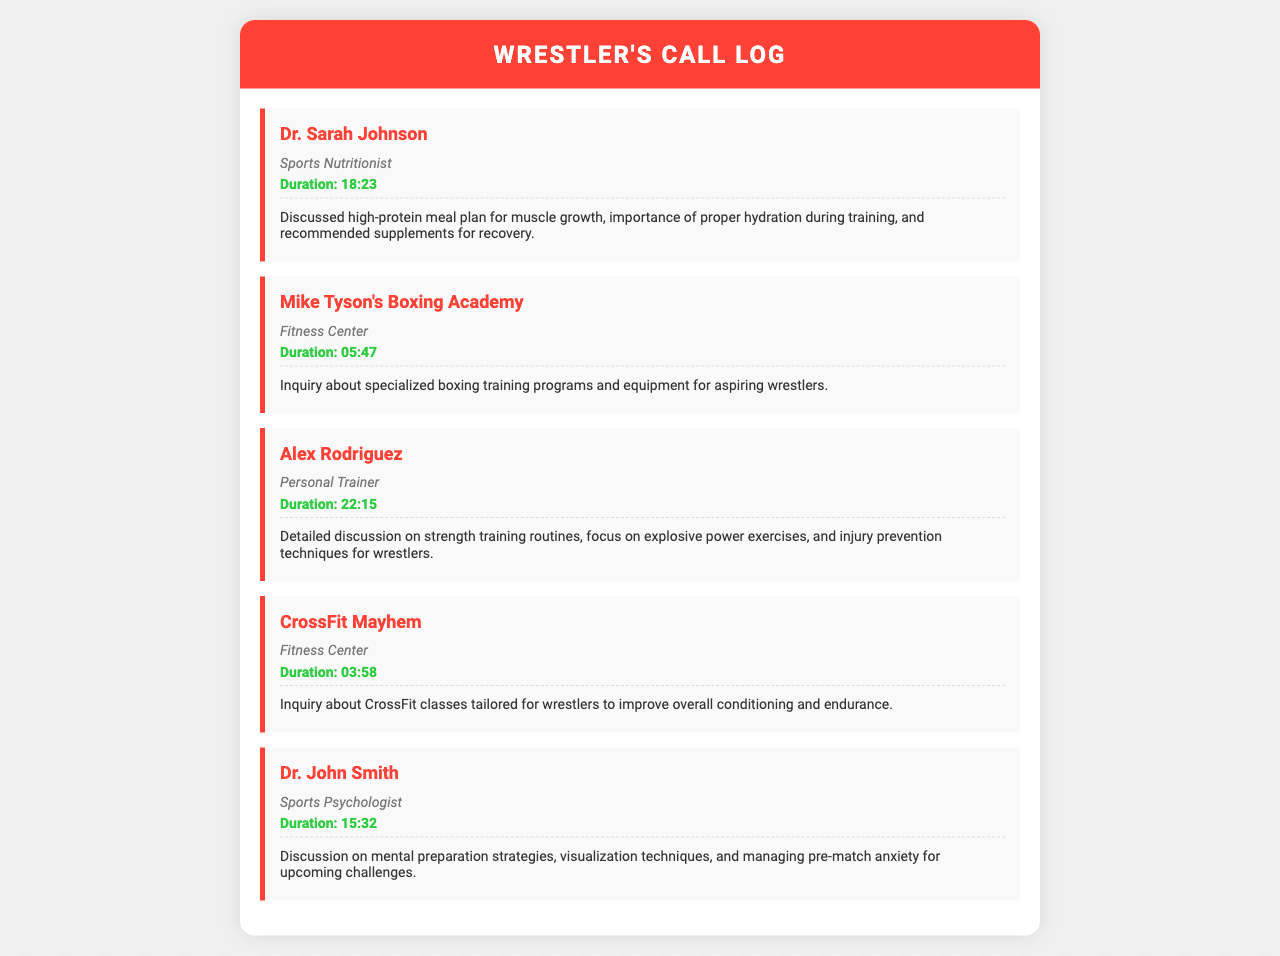What is the name of the sports nutritionist? The document lists "Dr. Sarah Johnson" as the sports nutritionist.
Answer: Dr. Sarah Johnson What is the duration of the call with Alex Rodriguez? The document shows that the call with Alex Rodriguez lasted for 22 minutes and 15 seconds.
Answer: 22:15 What discussion topics were covered in the call with Dr. John Smith? The topics discussed included mental preparation strategies and managing pre-match anxiety.
Answer: Mental preparation strategies, visualization techniques, managing pre-match anxiety How long was the call with CrossFit Mayhem? According to the record, the call with CrossFit Mayhem lasted for 3 minutes and 58 seconds.
Answer: 03:58 What type of training programs were discussed during the call with Mike Tyson's Boxing Academy? The call included an inquiry about specialized boxing training programs.
Answer: Specialized boxing training programs Which fitness center offers classes tailored for wrestlers? The document indicates that CrossFit Mayhem offers classes tailored for wrestlers.
Answer: CrossFit Mayhem What was the main focus of the call with Alex Rodriguez? The focus was on strength training routines and injury prevention techniques for wrestlers.
Answer: Strength training routines, injury prevention techniques How many calls were made to fitness centers? The document shows there were two calls made to fitness centers: Mike Tyson's Boxing Academy and CrossFit Mayhem.
Answer: 2 